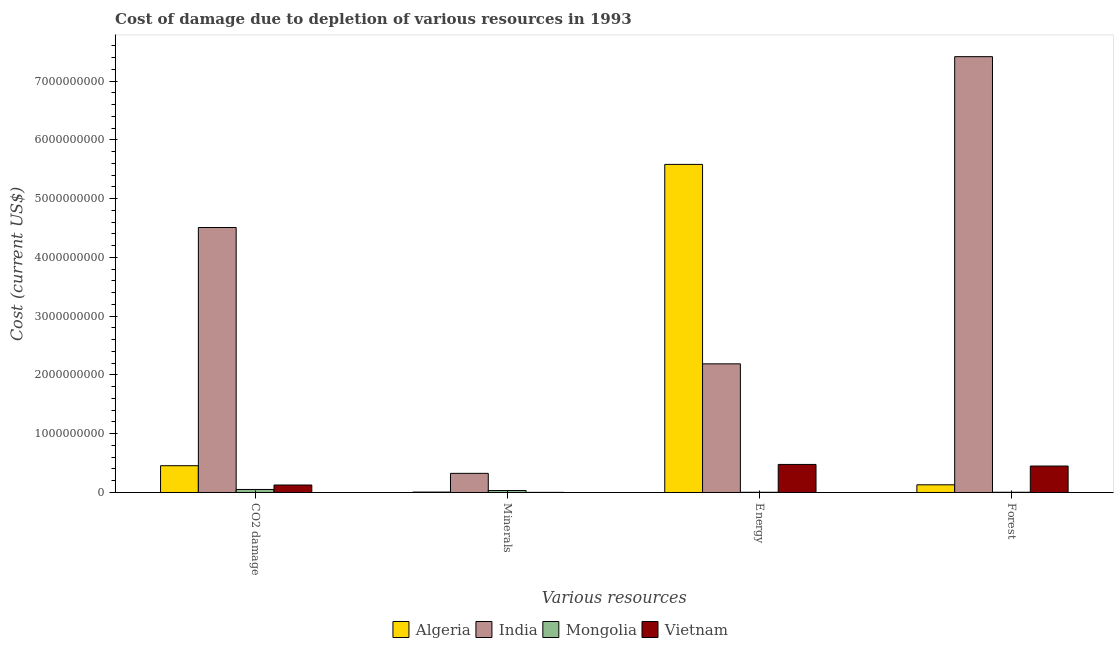Are the number of bars per tick equal to the number of legend labels?
Offer a very short reply. Yes. What is the label of the 1st group of bars from the left?
Keep it short and to the point. CO2 damage. What is the cost of damage due to depletion of energy in India?
Ensure brevity in your answer.  2.19e+09. Across all countries, what is the maximum cost of damage due to depletion of minerals?
Ensure brevity in your answer.  3.26e+08. Across all countries, what is the minimum cost of damage due to depletion of minerals?
Give a very brief answer. 2.00e+06. In which country was the cost of damage due to depletion of energy maximum?
Provide a succinct answer. Algeria. In which country was the cost of damage due to depletion of energy minimum?
Provide a short and direct response. Mongolia. What is the total cost of damage due to depletion of energy in the graph?
Your response must be concise. 8.25e+09. What is the difference between the cost of damage due to depletion of minerals in Algeria and that in Mongolia?
Your answer should be very brief. -2.66e+07. What is the difference between the cost of damage due to depletion of forests in Algeria and the cost of damage due to depletion of energy in Mongolia?
Offer a very short reply. 1.27e+08. What is the average cost of damage due to depletion of energy per country?
Make the answer very short. 2.06e+09. What is the difference between the cost of damage due to depletion of coal and cost of damage due to depletion of forests in Mongolia?
Provide a succinct answer. 4.76e+07. What is the ratio of the cost of damage due to depletion of minerals in Algeria to that in Vietnam?
Provide a short and direct response. 3.4. Is the cost of damage due to depletion of energy in India less than that in Vietnam?
Offer a terse response. No. Is the difference between the cost of damage due to depletion of forests in Algeria and Mongolia greater than the difference between the cost of damage due to depletion of minerals in Algeria and Mongolia?
Offer a very short reply. Yes. What is the difference between the highest and the second highest cost of damage due to depletion of energy?
Give a very brief answer. 3.39e+09. What is the difference between the highest and the lowest cost of damage due to depletion of minerals?
Your answer should be very brief. 3.24e+08. In how many countries, is the cost of damage due to depletion of forests greater than the average cost of damage due to depletion of forests taken over all countries?
Provide a short and direct response. 1. Is the sum of the cost of damage due to depletion of energy in Vietnam and Algeria greater than the maximum cost of damage due to depletion of minerals across all countries?
Keep it short and to the point. Yes. Is it the case that in every country, the sum of the cost of damage due to depletion of minerals and cost of damage due to depletion of forests is greater than the sum of cost of damage due to depletion of energy and cost of damage due to depletion of coal?
Your response must be concise. No. What does the 2nd bar from the left in Minerals represents?
Provide a succinct answer. India. What does the 1st bar from the right in CO2 damage represents?
Provide a succinct answer. Vietnam. Are all the bars in the graph horizontal?
Keep it short and to the point. No. How many countries are there in the graph?
Make the answer very short. 4. Does the graph contain any zero values?
Your answer should be very brief. No. Where does the legend appear in the graph?
Offer a very short reply. Bottom center. How many legend labels are there?
Your answer should be very brief. 4. What is the title of the graph?
Ensure brevity in your answer.  Cost of damage due to depletion of various resources in 1993 . Does "Belize" appear as one of the legend labels in the graph?
Keep it short and to the point. No. What is the label or title of the X-axis?
Ensure brevity in your answer.  Various resources. What is the label or title of the Y-axis?
Give a very brief answer. Cost (current US$). What is the Cost (current US$) in Algeria in CO2 damage?
Your answer should be compact. 4.56e+08. What is the Cost (current US$) of India in CO2 damage?
Your response must be concise. 4.51e+09. What is the Cost (current US$) in Mongolia in CO2 damage?
Provide a short and direct response. 5.16e+07. What is the Cost (current US$) of Vietnam in CO2 damage?
Your answer should be compact. 1.27e+08. What is the Cost (current US$) of Algeria in Minerals?
Your response must be concise. 6.81e+06. What is the Cost (current US$) of India in Minerals?
Your answer should be very brief. 3.26e+08. What is the Cost (current US$) in Mongolia in Minerals?
Ensure brevity in your answer.  3.34e+07. What is the Cost (current US$) of Vietnam in Minerals?
Offer a very short reply. 2.00e+06. What is the Cost (current US$) in Algeria in Energy?
Offer a terse response. 5.58e+09. What is the Cost (current US$) in India in Energy?
Your response must be concise. 2.19e+09. What is the Cost (current US$) in Mongolia in Energy?
Give a very brief answer. 3.76e+06. What is the Cost (current US$) in Vietnam in Energy?
Your response must be concise. 4.77e+08. What is the Cost (current US$) in Algeria in Forest?
Make the answer very short. 1.31e+08. What is the Cost (current US$) of India in Forest?
Provide a succinct answer. 7.42e+09. What is the Cost (current US$) in Mongolia in Forest?
Your response must be concise. 3.94e+06. What is the Cost (current US$) of Vietnam in Forest?
Your response must be concise. 4.50e+08. Across all Various resources, what is the maximum Cost (current US$) in Algeria?
Offer a very short reply. 5.58e+09. Across all Various resources, what is the maximum Cost (current US$) in India?
Ensure brevity in your answer.  7.42e+09. Across all Various resources, what is the maximum Cost (current US$) in Mongolia?
Ensure brevity in your answer.  5.16e+07. Across all Various resources, what is the maximum Cost (current US$) in Vietnam?
Keep it short and to the point. 4.77e+08. Across all Various resources, what is the minimum Cost (current US$) in Algeria?
Ensure brevity in your answer.  6.81e+06. Across all Various resources, what is the minimum Cost (current US$) in India?
Offer a terse response. 3.26e+08. Across all Various resources, what is the minimum Cost (current US$) in Mongolia?
Offer a very short reply. 3.76e+06. Across all Various resources, what is the minimum Cost (current US$) of Vietnam?
Your response must be concise. 2.00e+06. What is the total Cost (current US$) in Algeria in the graph?
Offer a terse response. 6.18e+09. What is the total Cost (current US$) of India in the graph?
Your response must be concise. 1.44e+1. What is the total Cost (current US$) of Mongolia in the graph?
Give a very brief answer. 9.27e+07. What is the total Cost (current US$) in Vietnam in the graph?
Provide a succinct answer. 1.06e+09. What is the difference between the Cost (current US$) of Algeria in CO2 damage and that in Minerals?
Offer a terse response. 4.49e+08. What is the difference between the Cost (current US$) of India in CO2 damage and that in Minerals?
Make the answer very short. 4.18e+09. What is the difference between the Cost (current US$) of Mongolia in CO2 damage and that in Minerals?
Keep it short and to the point. 1.82e+07. What is the difference between the Cost (current US$) of Vietnam in CO2 damage and that in Minerals?
Ensure brevity in your answer.  1.25e+08. What is the difference between the Cost (current US$) of Algeria in CO2 damage and that in Energy?
Offer a terse response. -5.13e+09. What is the difference between the Cost (current US$) in India in CO2 damage and that in Energy?
Offer a very short reply. 2.32e+09. What is the difference between the Cost (current US$) of Mongolia in CO2 damage and that in Energy?
Offer a very short reply. 4.78e+07. What is the difference between the Cost (current US$) of Vietnam in CO2 damage and that in Energy?
Your response must be concise. -3.50e+08. What is the difference between the Cost (current US$) in Algeria in CO2 damage and that in Forest?
Your response must be concise. 3.25e+08. What is the difference between the Cost (current US$) in India in CO2 damage and that in Forest?
Provide a succinct answer. -2.91e+09. What is the difference between the Cost (current US$) of Mongolia in CO2 damage and that in Forest?
Ensure brevity in your answer.  4.76e+07. What is the difference between the Cost (current US$) of Vietnam in CO2 damage and that in Forest?
Your response must be concise. -3.23e+08. What is the difference between the Cost (current US$) of Algeria in Minerals and that in Energy?
Keep it short and to the point. -5.58e+09. What is the difference between the Cost (current US$) in India in Minerals and that in Energy?
Make the answer very short. -1.86e+09. What is the difference between the Cost (current US$) in Mongolia in Minerals and that in Energy?
Offer a very short reply. 2.96e+07. What is the difference between the Cost (current US$) in Vietnam in Minerals and that in Energy?
Your response must be concise. -4.75e+08. What is the difference between the Cost (current US$) of Algeria in Minerals and that in Forest?
Your answer should be very brief. -1.24e+08. What is the difference between the Cost (current US$) of India in Minerals and that in Forest?
Your answer should be compact. -7.09e+09. What is the difference between the Cost (current US$) of Mongolia in Minerals and that in Forest?
Provide a succinct answer. 2.94e+07. What is the difference between the Cost (current US$) in Vietnam in Minerals and that in Forest?
Offer a very short reply. -4.48e+08. What is the difference between the Cost (current US$) in Algeria in Energy and that in Forest?
Make the answer very short. 5.45e+09. What is the difference between the Cost (current US$) in India in Energy and that in Forest?
Offer a very short reply. -5.23e+09. What is the difference between the Cost (current US$) of Mongolia in Energy and that in Forest?
Give a very brief answer. -1.79e+05. What is the difference between the Cost (current US$) in Vietnam in Energy and that in Forest?
Ensure brevity in your answer.  2.75e+07. What is the difference between the Cost (current US$) in Algeria in CO2 damage and the Cost (current US$) in India in Minerals?
Your answer should be very brief. 1.30e+08. What is the difference between the Cost (current US$) in Algeria in CO2 damage and the Cost (current US$) in Mongolia in Minerals?
Your answer should be very brief. 4.22e+08. What is the difference between the Cost (current US$) in Algeria in CO2 damage and the Cost (current US$) in Vietnam in Minerals?
Offer a very short reply. 4.54e+08. What is the difference between the Cost (current US$) in India in CO2 damage and the Cost (current US$) in Mongolia in Minerals?
Offer a very short reply. 4.48e+09. What is the difference between the Cost (current US$) in India in CO2 damage and the Cost (current US$) in Vietnam in Minerals?
Offer a very short reply. 4.51e+09. What is the difference between the Cost (current US$) in Mongolia in CO2 damage and the Cost (current US$) in Vietnam in Minerals?
Your answer should be very brief. 4.96e+07. What is the difference between the Cost (current US$) in Algeria in CO2 damage and the Cost (current US$) in India in Energy?
Provide a succinct answer. -1.73e+09. What is the difference between the Cost (current US$) in Algeria in CO2 damage and the Cost (current US$) in Mongolia in Energy?
Your answer should be compact. 4.52e+08. What is the difference between the Cost (current US$) in Algeria in CO2 damage and the Cost (current US$) in Vietnam in Energy?
Give a very brief answer. -2.18e+07. What is the difference between the Cost (current US$) of India in CO2 damage and the Cost (current US$) of Mongolia in Energy?
Provide a short and direct response. 4.51e+09. What is the difference between the Cost (current US$) of India in CO2 damage and the Cost (current US$) of Vietnam in Energy?
Offer a terse response. 4.03e+09. What is the difference between the Cost (current US$) in Mongolia in CO2 damage and the Cost (current US$) in Vietnam in Energy?
Give a very brief answer. -4.26e+08. What is the difference between the Cost (current US$) in Algeria in CO2 damage and the Cost (current US$) in India in Forest?
Your answer should be compact. -6.96e+09. What is the difference between the Cost (current US$) in Algeria in CO2 damage and the Cost (current US$) in Mongolia in Forest?
Give a very brief answer. 4.52e+08. What is the difference between the Cost (current US$) of Algeria in CO2 damage and the Cost (current US$) of Vietnam in Forest?
Provide a short and direct response. 5.67e+06. What is the difference between the Cost (current US$) of India in CO2 damage and the Cost (current US$) of Mongolia in Forest?
Keep it short and to the point. 4.50e+09. What is the difference between the Cost (current US$) in India in CO2 damage and the Cost (current US$) in Vietnam in Forest?
Ensure brevity in your answer.  4.06e+09. What is the difference between the Cost (current US$) in Mongolia in CO2 damage and the Cost (current US$) in Vietnam in Forest?
Your answer should be compact. -3.98e+08. What is the difference between the Cost (current US$) of Algeria in Minerals and the Cost (current US$) of India in Energy?
Your answer should be compact. -2.18e+09. What is the difference between the Cost (current US$) in Algeria in Minerals and the Cost (current US$) in Mongolia in Energy?
Your answer should be compact. 3.06e+06. What is the difference between the Cost (current US$) of Algeria in Minerals and the Cost (current US$) of Vietnam in Energy?
Ensure brevity in your answer.  -4.71e+08. What is the difference between the Cost (current US$) in India in Minerals and the Cost (current US$) in Mongolia in Energy?
Ensure brevity in your answer.  3.22e+08. What is the difference between the Cost (current US$) in India in Minerals and the Cost (current US$) in Vietnam in Energy?
Ensure brevity in your answer.  -1.52e+08. What is the difference between the Cost (current US$) in Mongolia in Minerals and the Cost (current US$) in Vietnam in Energy?
Offer a terse response. -4.44e+08. What is the difference between the Cost (current US$) in Algeria in Minerals and the Cost (current US$) in India in Forest?
Give a very brief answer. -7.41e+09. What is the difference between the Cost (current US$) in Algeria in Minerals and the Cost (current US$) in Mongolia in Forest?
Provide a short and direct response. 2.88e+06. What is the difference between the Cost (current US$) of Algeria in Minerals and the Cost (current US$) of Vietnam in Forest?
Offer a terse response. -4.43e+08. What is the difference between the Cost (current US$) of India in Minerals and the Cost (current US$) of Mongolia in Forest?
Your response must be concise. 3.22e+08. What is the difference between the Cost (current US$) in India in Minerals and the Cost (current US$) in Vietnam in Forest?
Make the answer very short. -1.24e+08. What is the difference between the Cost (current US$) of Mongolia in Minerals and the Cost (current US$) of Vietnam in Forest?
Provide a short and direct response. -4.17e+08. What is the difference between the Cost (current US$) of Algeria in Energy and the Cost (current US$) of India in Forest?
Give a very brief answer. -1.83e+09. What is the difference between the Cost (current US$) of Algeria in Energy and the Cost (current US$) of Mongolia in Forest?
Your answer should be very brief. 5.58e+09. What is the difference between the Cost (current US$) of Algeria in Energy and the Cost (current US$) of Vietnam in Forest?
Make the answer very short. 5.13e+09. What is the difference between the Cost (current US$) of India in Energy and the Cost (current US$) of Mongolia in Forest?
Your response must be concise. 2.19e+09. What is the difference between the Cost (current US$) of India in Energy and the Cost (current US$) of Vietnam in Forest?
Keep it short and to the point. 1.74e+09. What is the difference between the Cost (current US$) in Mongolia in Energy and the Cost (current US$) in Vietnam in Forest?
Offer a very short reply. -4.46e+08. What is the average Cost (current US$) of Algeria per Various resources?
Ensure brevity in your answer.  1.54e+09. What is the average Cost (current US$) of India per Various resources?
Provide a short and direct response. 3.61e+09. What is the average Cost (current US$) of Mongolia per Various resources?
Your answer should be very brief. 2.32e+07. What is the average Cost (current US$) in Vietnam per Various resources?
Your response must be concise. 2.64e+08. What is the difference between the Cost (current US$) of Algeria and Cost (current US$) of India in CO2 damage?
Your answer should be compact. -4.05e+09. What is the difference between the Cost (current US$) of Algeria and Cost (current US$) of Mongolia in CO2 damage?
Your answer should be compact. 4.04e+08. What is the difference between the Cost (current US$) in Algeria and Cost (current US$) in Vietnam in CO2 damage?
Provide a short and direct response. 3.28e+08. What is the difference between the Cost (current US$) of India and Cost (current US$) of Mongolia in CO2 damage?
Provide a short and direct response. 4.46e+09. What is the difference between the Cost (current US$) in India and Cost (current US$) in Vietnam in CO2 damage?
Provide a short and direct response. 4.38e+09. What is the difference between the Cost (current US$) of Mongolia and Cost (current US$) of Vietnam in CO2 damage?
Your answer should be very brief. -7.58e+07. What is the difference between the Cost (current US$) of Algeria and Cost (current US$) of India in Minerals?
Your response must be concise. -3.19e+08. What is the difference between the Cost (current US$) in Algeria and Cost (current US$) in Mongolia in Minerals?
Make the answer very short. -2.66e+07. What is the difference between the Cost (current US$) of Algeria and Cost (current US$) of Vietnam in Minerals?
Your response must be concise. 4.81e+06. What is the difference between the Cost (current US$) in India and Cost (current US$) in Mongolia in Minerals?
Provide a succinct answer. 2.92e+08. What is the difference between the Cost (current US$) in India and Cost (current US$) in Vietnam in Minerals?
Your answer should be compact. 3.24e+08. What is the difference between the Cost (current US$) of Mongolia and Cost (current US$) of Vietnam in Minerals?
Ensure brevity in your answer.  3.14e+07. What is the difference between the Cost (current US$) in Algeria and Cost (current US$) in India in Energy?
Make the answer very short. 3.39e+09. What is the difference between the Cost (current US$) in Algeria and Cost (current US$) in Mongolia in Energy?
Your answer should be very brief. 5.58e+09. What is the difference between the Cost (current US$) in Algeria and Cost (current US$) in Vietnam in Energy?
Ensure brevity in your answer.  5.11e+09. What is the difference between the Cost (current US$) of India and Cost (current US$) of Mongolia in Energy?
Offer a very short reply. 2.19e+09. What is the difference between the Cost (current US$) in India and Cost (current US$) in Vietnam in Energy?
Your answer should be compact. 1.71e+09. What is the difference between the Cost (current US$) of Mongolia and Cost (current US$) of Vietnam in Energy?
Your response must be concise. -4.74e+08. What is the difference between the Cost (current US$) of Algeria and Cost (current US$) of India in Forest?
Your answer should be very brief. -7.29e+09. What is the difference between the Cost (current US$) of Algeria and Cost (current US$) of Mongolia in Forest?
Your response must be concise. 1.27e+08. What is the difference between the Cost (current US$) of Algeria and Cost (current US$) of Vietnam in Forest?
Make the answer very short. -3.19e+08. What is the difference between the Cost (current US$) in India and Cost (current US$) in Mongolia in Forest?
Provide a short and direct response. 7.41e+09. What is the difference between the Cost (current US$) of India and Cost (current US$) of Vietnam in Forest?
Provide a succinct answer. 6.97e+09. What is the difference between the Cost (current US$) of Mongolia and Cost (current US$) of Vietnam in Forest?
Provide a short and direct response. -4.46e+08. What is the ratio of the Cost (current US$) in Algeria in CO2 damage to that in Minerals?
Keep it short and to the point. 66.88. What is the ratio of the Cost (current US$) of India in CO2 damage to that in Minerals?
Make the answer very short. 13.85. What is the ratio of the Cost (current US$) of Mongolia in CO2 damage to that in Minerals?
Offer a terse response. 1.54. What is the ratio of the Cost (current US$) of Vietnam in CO2 damage to that in Minerals?
Your response must be concise. 63.64. What is the ratio of the Cost (current US$) in Algeria in CO2 damage to that in Energy?
Offer a very short reply. 0.08. What is the ratio of the Cost (current US$) in India in CO2 damage to that in Energy?
Give a very brief answer. 2.06. What is the ratio of the Cost (current US$) in Mongolia in CO2 damage to that in Energy?
Give a very brief answer. 13.72. What is the ratio of the Cost (current US$) in Vietnam in CO2 damage to that in Energy?
Your answer should be compact. 0.27. What is the ratio of the Cost (current US$) of Algeria in CO2 damage to that in Forest?
Your response must be concise. 3.48. What is the ratio of the Cost (current US$) of India in CO2 damage to that in Forest?
Make the answer very short. 0.61. What is the ratio of the Cost (current US$) of Mongolia in CO2 damage to that in Forest?
Keep it short and to the point. 13.1. What is the ratio of the Cost (current US$) of Vietnam in CO2 damage to that in Forest?
Keep it short and to the point. 0.28. What is the ratio of the Cost (current US$) in Algeria in Minerals to that in Energy?
Provide a succinct answer. 0. What is the ratio of the Cost (current US$) of India in Minerals to that in Energy?
Ensure brevity in your answer.  0.15. What is the ratio of the Cost (current US$) of Mongolia in Minerals to that in Energy?
Provide a short and direct response. 8.88. What is the ratio of the Cost (current US$) in Vietnam in Minerals to that in Energy?
Make the answer very short. 0. What is the ratio of the Cost (current US$) of Algeria in Minerals to that in Forest?
Make the answer very short. 0.05. What is the ratio of the Cost (current US$) of India in Minerals to that in Forest?
Give a very brief answer. 0.04. What is the ratio of the Cost (current US$) of Mongolia in Minerals to that in Forest?
Your answer should be compact. 8.48. What is the ratio of the Cost (current US$) in Vietnam in Minerals to that in Forest?
Provide a succinct answer. 0. What is the ratio of the Cost (current US$) of Algeria in Energy to that in Forest?
Ensure brevity in your answer.  42.68. What is the ratio of the Cost (current US$) in India in Energy to that in Forest?
Your response must be concise. 0.3. What is the ratio of the Cost (current US$) of Mongolia in Energy to that in Forest?
Your answer should be compact. 0.95. What is the ratio of the Cost (current US$) in Vietnam in Energy to that in Forest?
Your answer should be very brief. 1.06. What is the difference between the highest and the second highest Cost (current US$) in Algeria?
Ensure brevity in your answer.  5.13e+09. What is the difference between the highest and the second highest Cost (current US$) in India?
Your response must be concise. 2.91e+09. What is the difference between the highest and the second highest Cost (current US$) of Mongolia?
Your answer should be very brief. 1.82e+07. What is the difference between the highest and the second highest Cost (current US$) in Vietnam?
Your response must be concise. 2.75e+07. What is the difference between the highest and the lowest Cost (current US$) in Algeria?
Ensure brevity in your answer.  5.58e+09. What is the difference between the highest and the lowest Cost (current US$) in India?
Your answer should be very brief. 7.09e+09. What is the difference between the highest and the lowest Cost (current US$) in Mongolia?
Your response must be concise. 4.78e+07. What is the difference between the highest and the lowest Cost (current US$) in Vietnam?
Your answer should be very brief. 4.75e+08. 